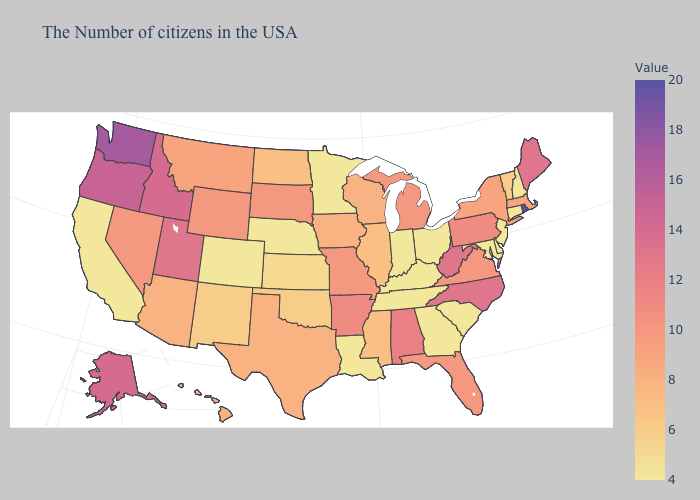Is the legend a continuous bar?
Keep it brief. Yes. Does Delaware have the lowest value in the USA?
Write a very short answer. Yes. Does Rhode Island have the highest value in the USA?
Concise answer only. Yes. Does Ohio have the lowest value in the MidWest?
Give a very brief answer. Yes. 